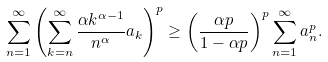Convert formula to latex. <formula><loc_0><loc_0><loc_500><loc_500>\sum ^ { \infty } _ { n = 1 } \left ( \sum ^ { \infty } _ { k = n } \frac { \alpha k ^ { \alpha - 1 } } { n ^ { \alpha } } a _ { k } \right ) ^ { p } \geq \left ( \frac { \alpha p } { 1 - \alpha p } \right ) ^ { p } \sum ^ { \infty } _ { n = 1 } a ^ { p } _ { n } .</formula> 